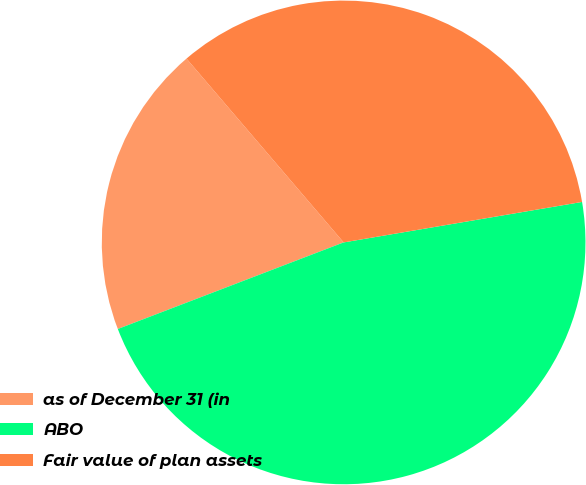Convert chart. <chart><loc_0><loc_0><loc_500><loc_500><pie_chart><fcel>as of December 31 (in<fcel>ABO<fcel>Fair value of plan assets<nl><fcel>19.57%<fcel>46.85%<fcel>33.58%<nl></chart> 